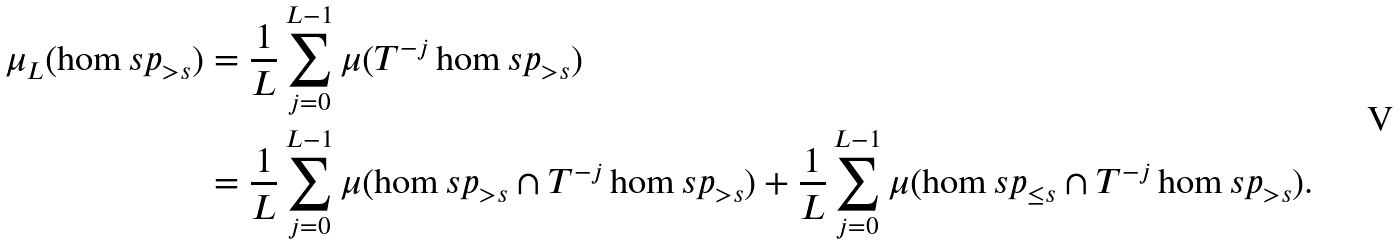<formula> <loc_0><loc_0><loc_500><loc_500>\mu _ { L } ( \hom s p _ { > s } ) & = \frac { 1 } { L } \sum _ { j = 0 } ^ { L - 1 } \mu ( T ^ { - j } \hom s p _ { > s } ) \\ & = \frac { 1 } { L } \sum _ { j = 0 } ^ { L - 1 } \mu ( \hom s p _ { > s } \cap T ^ { - j } \hom s p _ { > s } ) + \frac { 1 } { L } \sum _ { j = 0 } ^ { L - 1 } \mu ( \hom s p _ { \leq s } \cap T ^ { - j } \hom s p _ { > s } ) .</formula> 